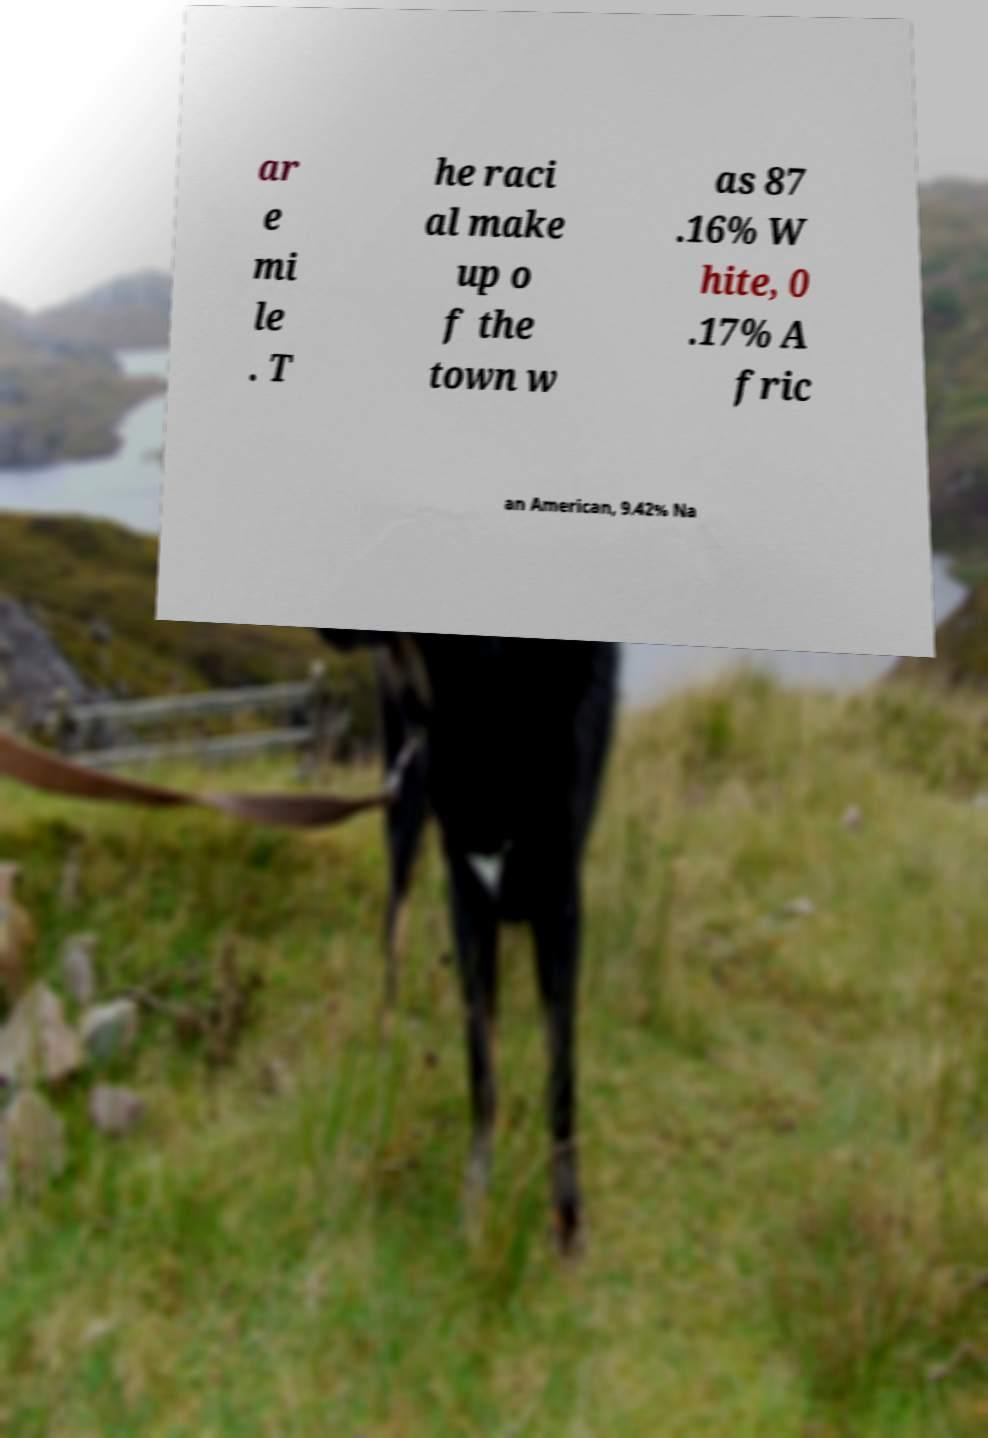Could you assist in decoding the text presented in this image and type it out clearly? ar e mi le . T he raci al make up o f the town w as 87 .16% W hite, 0 .17% A fric an American, 9.42% Na 